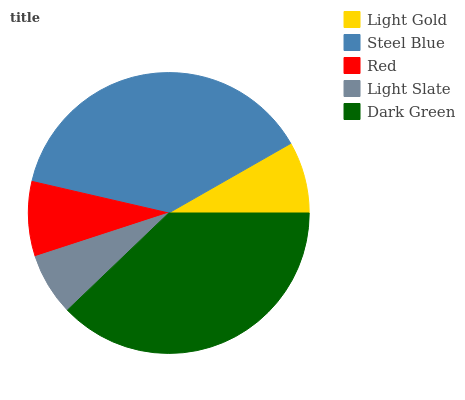Is Light Slate the minimum?
Answer yes or no. Yes. Is Steel Blue the maximum?
Answer yes or no. Yes. Is Red the minimum?
Answer yes or no. No. Is Red the maximum?
Answer yes or no. No. Is Steel Blue greater than Red?
Answer yes or no. Yes. Is Red less than Steel Blue?
Answer yes or no. Yes. Is Red greater than Steel Blue?
Answer yes or no. No. Is Steel Blue less than Red?
Answer yes or no. No. Is Red the high median?
Answer yes or no. Yes. Is Red the low median?
Answer yes or no. Yes. Is Light Gold the high median?
Answer yes or no. No. Is Light Gold the low median?
Answer yes or no. No. 